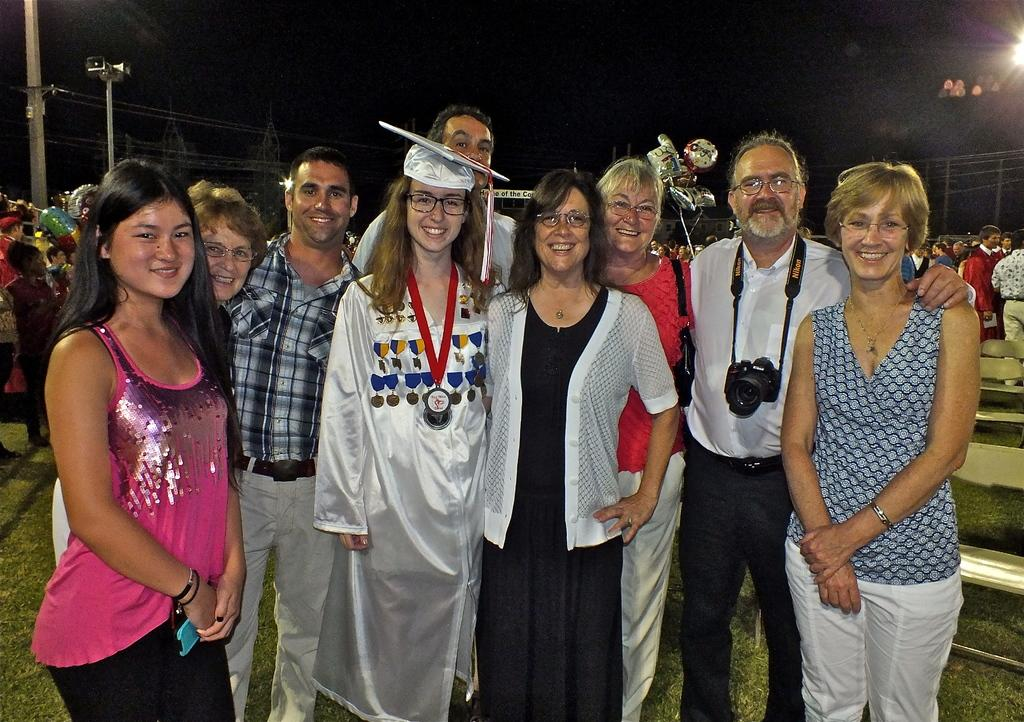How many people are in the image? There is a group of people in the image. What are the people in the image doing? The people are posing for a camera. What is the facial expression of the people in the image? The people are smiling. What type of terrain is visible in the image? There is grass in the image. What is the primary tool used to capture the image? There is a camera in the image. What are the tall, vertical structures in the image? There are poles in the image. What is the source of illumination in the image? There is a light in the image. Who else is present in the image besides the group of people? There are persons (presumably photographers or assistants) in the image. How would you describe the overall lighting conditions in the image? The background of the image is dark. What type of glue is being used to hold the team together in the image? There is no glue or team present in the image; it features a group of people posing for a camera. What kind of apparatus is being used by the people in the image? There is no apparatus present in the image; the people are simply posing for a camera. 